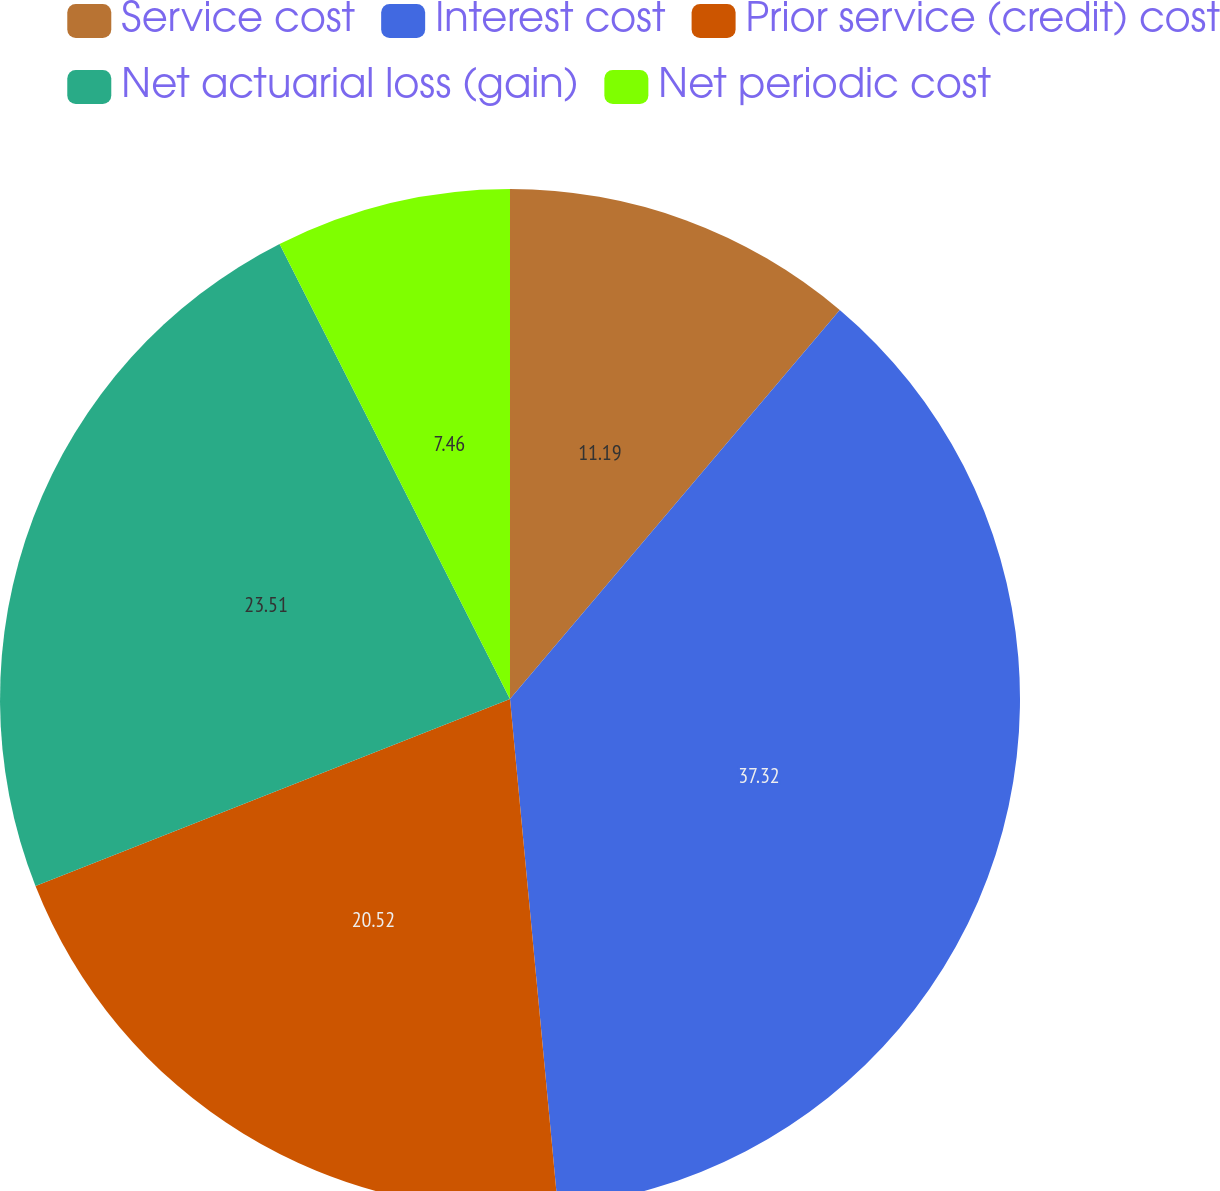Convert chart. <chart><loc_0><loc_0><loc_500><loc_500><pie_chart><fcel>Service cost<fcel>Interest cost<fcel>Prior service (credit) cost<fcel>Net actuarial loss (gain)<fcel>Net periodic cost<nl><fcel>11.19%<fcel>37.31%<fcel>20.52%<fcel>23.51%<fcel>7.46%<nl></chart> 